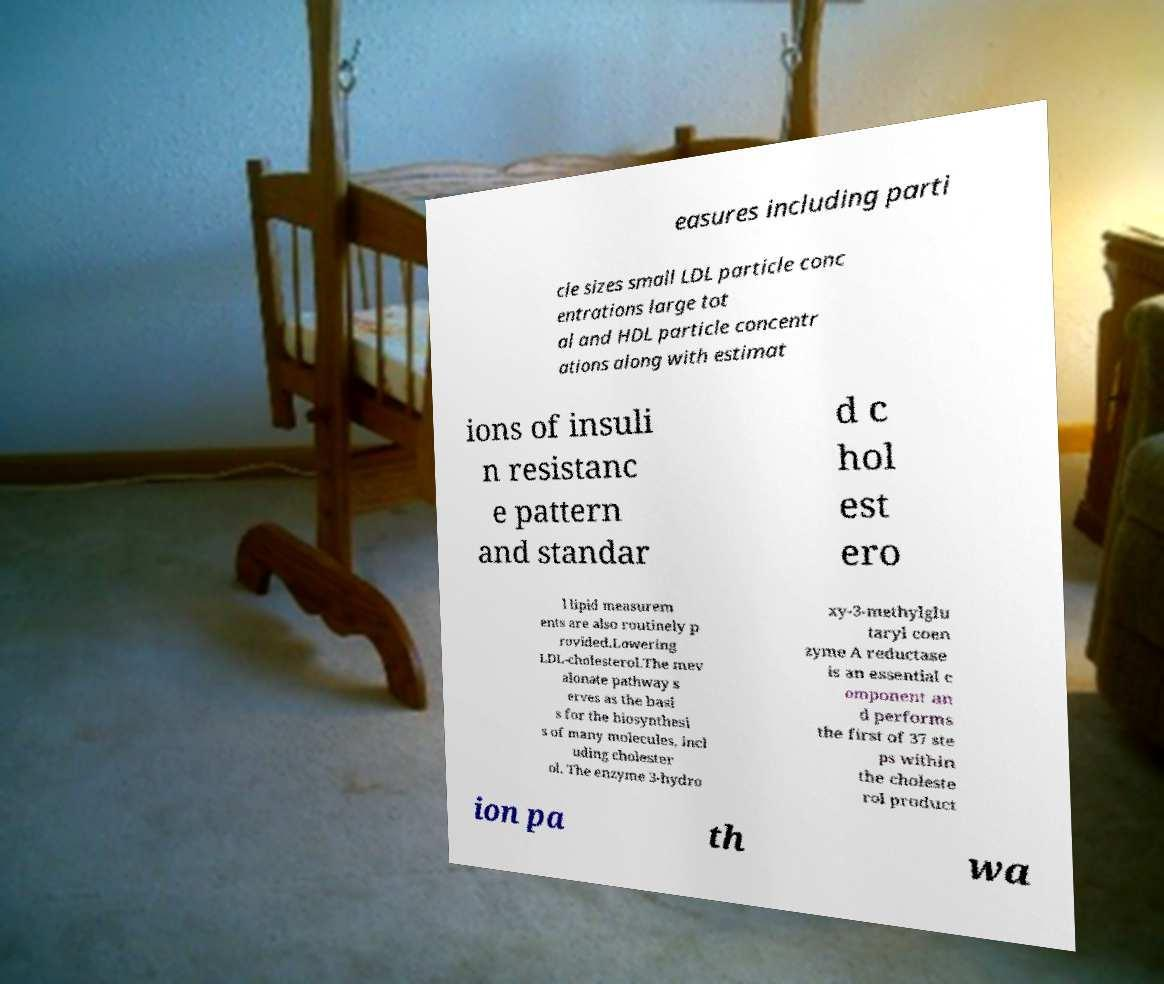For documentation purposes, I need the text within this image transcribed. Could you provide that? easures including parti cle sizes small LDL particle conc entrations large tot al and HDL particle concentr ations along with estimat ions of insuli n resistanc e pattern and standar d c hol est ero l lipid measurem ents are also routinely p rovided.Lowering LDL-cholesterol.The mev alonate pathway s erves as the basi s for the biosynthesi s of many molecules, incl uding cholester ol. The enzyme 3-hydro xy-3-methylglu taryl coen zyme A reductase is an essential c omponent an d performs the first of 37 ste ps within the choleste rol product ion pa th wa 